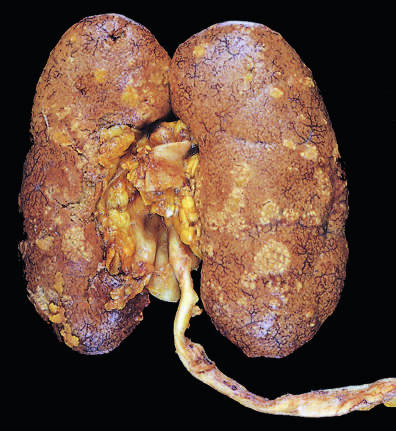s acute rheumatic mitral valvulitis dark congestion of the renal surface between the abscesses?
Answer the question using a single word or phrase. No 